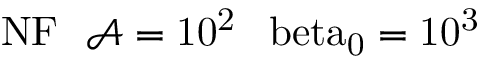<formula> <loc_0><loc_0><loc_500><loc_500>{ N F } \, \mathcal { A } = 1 0 ^ { 2 } \, \ b e t a _ { 0 } = 1 0 ^ { 3 }</formula> 